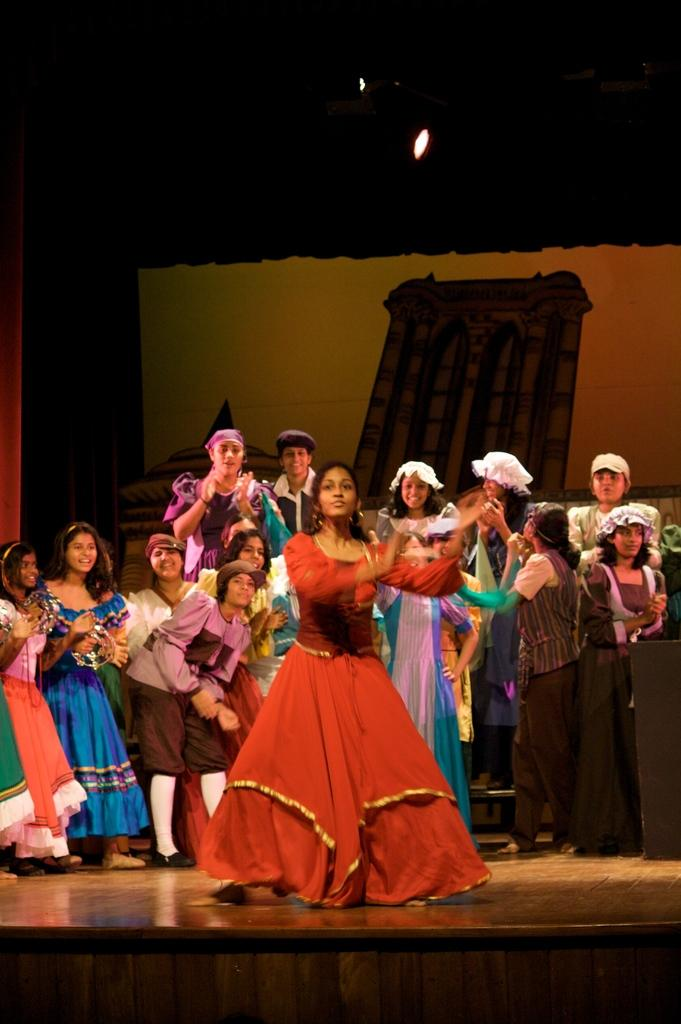What is the main subject in the foreground of the image? There is a girl in the foreground of the image. What is the girl doing in the image? The girl appears to be dancing. Are there any other people visible in the image? Yes, there are people standing behind the girl. What can be seen in the background of the image? There is an object and a spotlight in the background of the image. What type of organization is the girl a part of in the image? There is no information in the image to suggest that the girl is a part of any organization. Does the girl have a crush on anyone in the image? There is no information in the image to suggest that the girl has a crush on anyone. 